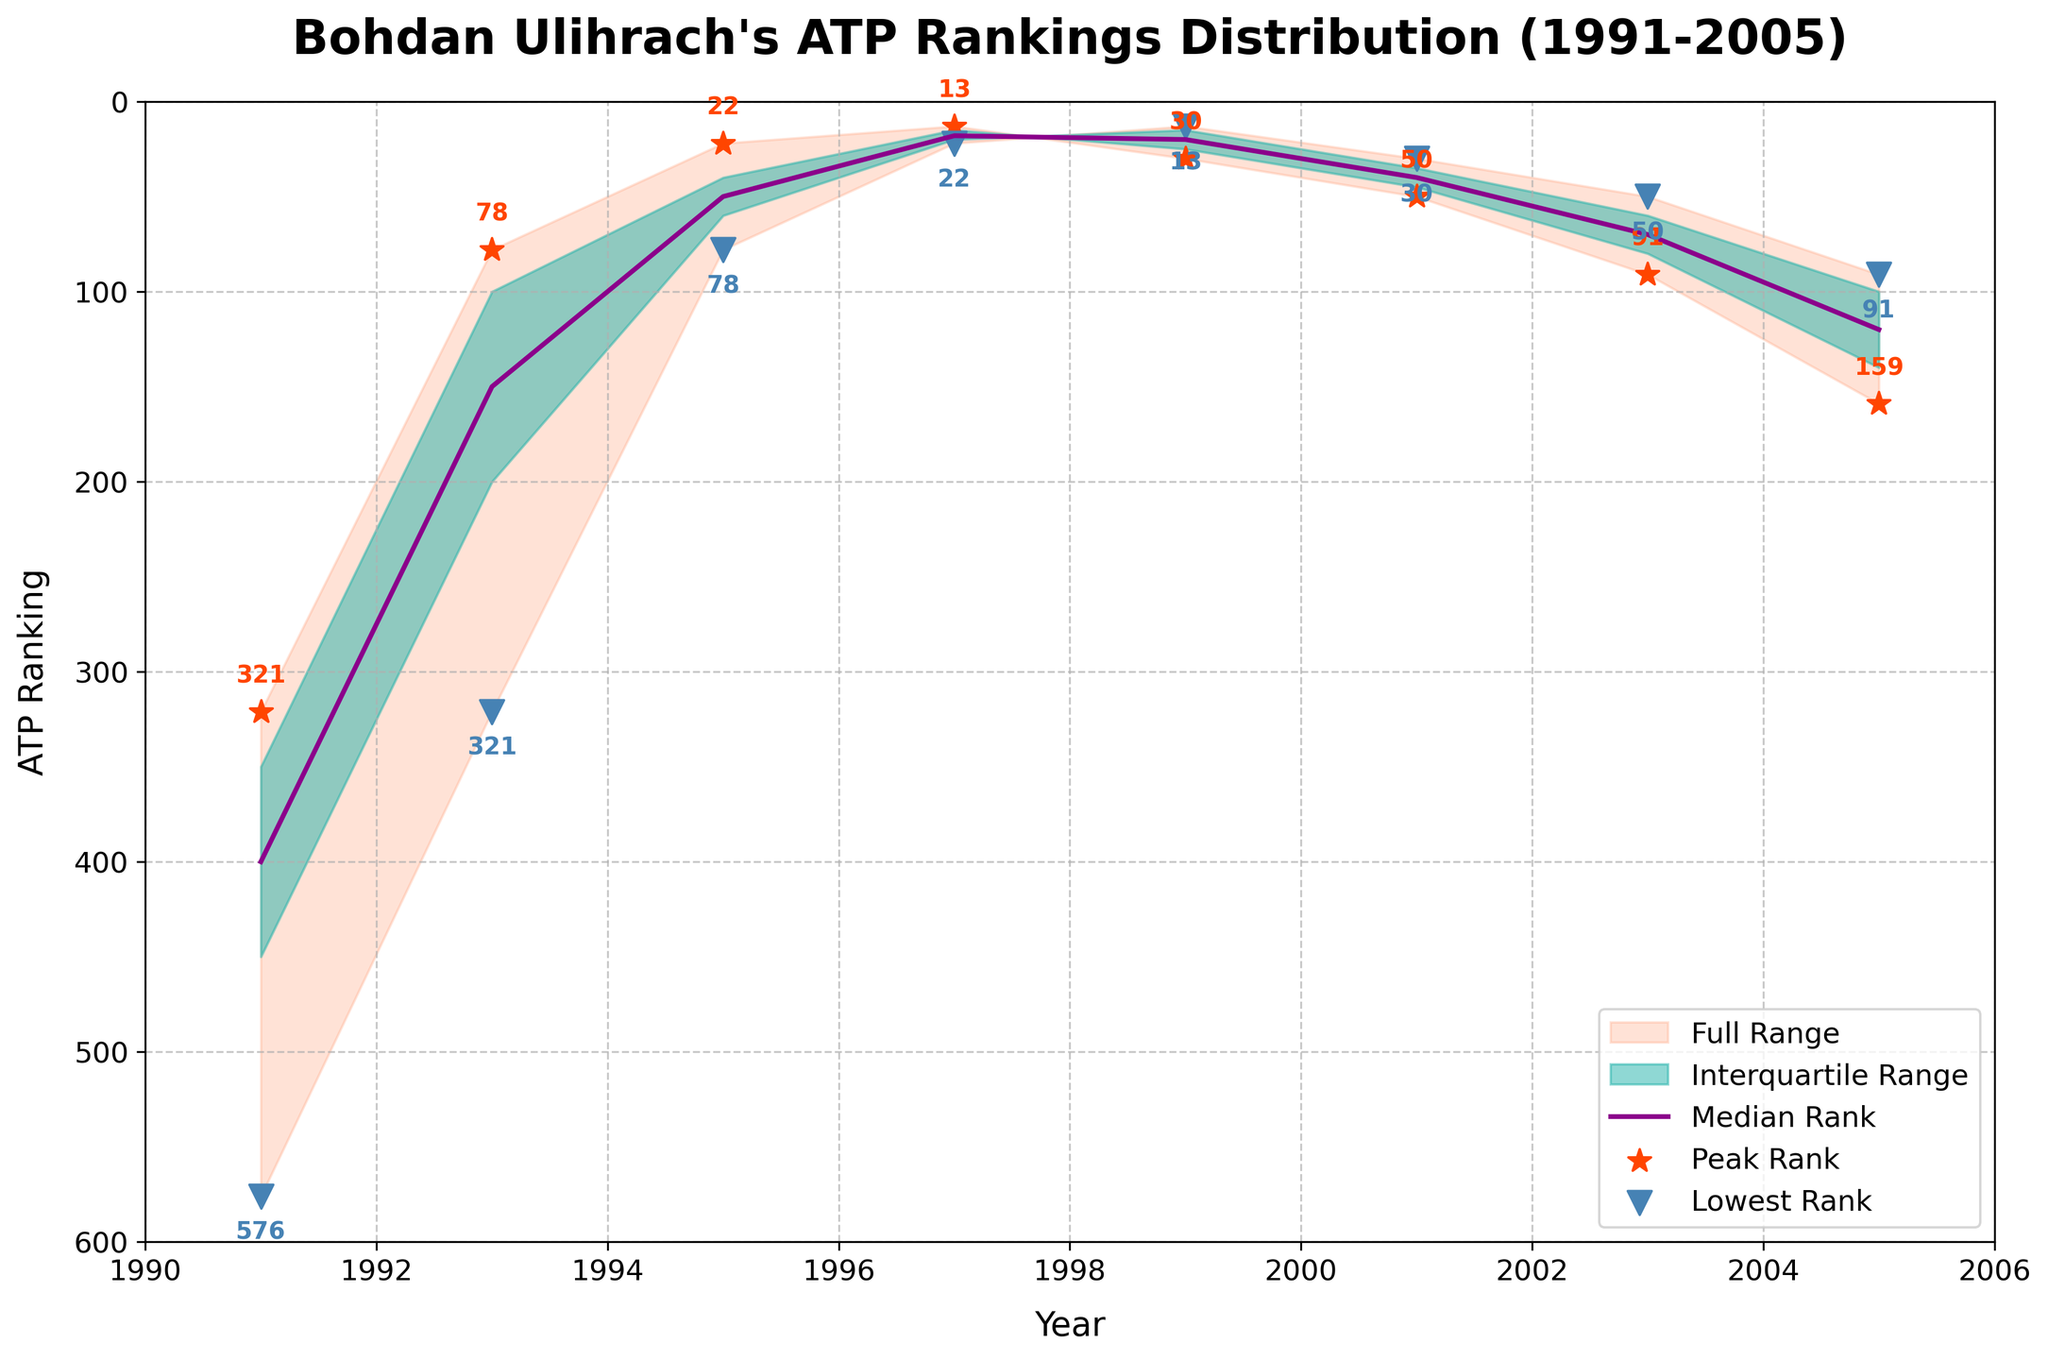What is the title of the figure? The title can be found at the top of the figure. It is usually in a larger font size.
Answer: Bohdan Ulihrach's ATP Rankings Distribution (1991-2005) What are the labels on the x-axis and y-axis? The labels are located at the bottom (x-axis) and left side (y-axis) of the figure.
Answer: Year (x-axis), ATP Ranking (y-axis) What is the range of ATP rankings shown on the y-axis? The y-axis range can be identified by looking at the values on the left side of the figure.
Answer: 600 to 0 Which year did Bohdan Ulihrach achieve his peak ATP rank, and what was that rank? The peak ATP rank can be determined by finding the star marker (*) on the line plot, and the corresponding year can be found using the x-axis.
Answer: 1997, 13 In which year is the median ATP rank at its lowest point, and what is the value? The median rank is represented by the central line in the plot. The lowest median rank can be identified by looking at which year this line dips the lowest on the y-axis.
Answer: 1997, 18 How many years are covered in the chart? Count the number of distinct data points on the x-axis or the labels.
Answer: 8 years What was the 25th percentile rank in 1999? The 25th percentile range is shown as the lower boundary of the interquartile range. Identify this value directly from the figure.
Answer: 15 